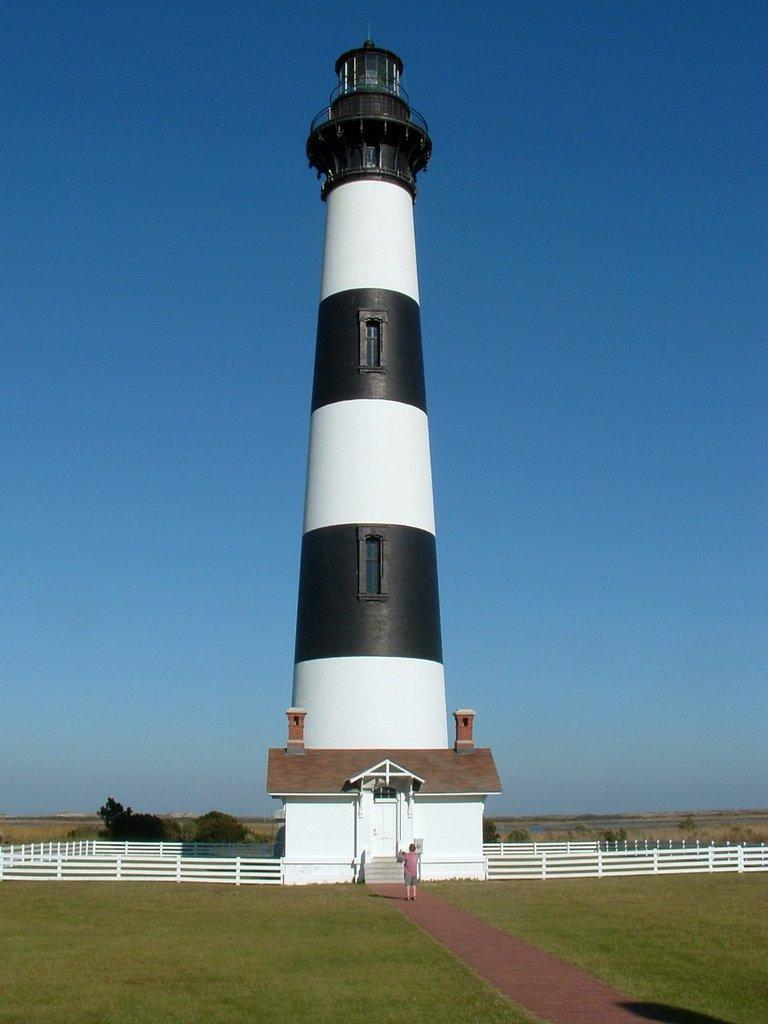Could you give a brief overview of what you see in this image? In the middle of this image, there is a tower in white and black color combination on the ground. Around this town, there is a white color fence. Besides this town, there is a building which is having a roof and a door. Besides this building, there are steps. Beside these steps, there is a person on a path. On both sides of this path, there is grass. In the background, there are trees, plants and grass on the ground and there are clouds in the blue sky. 